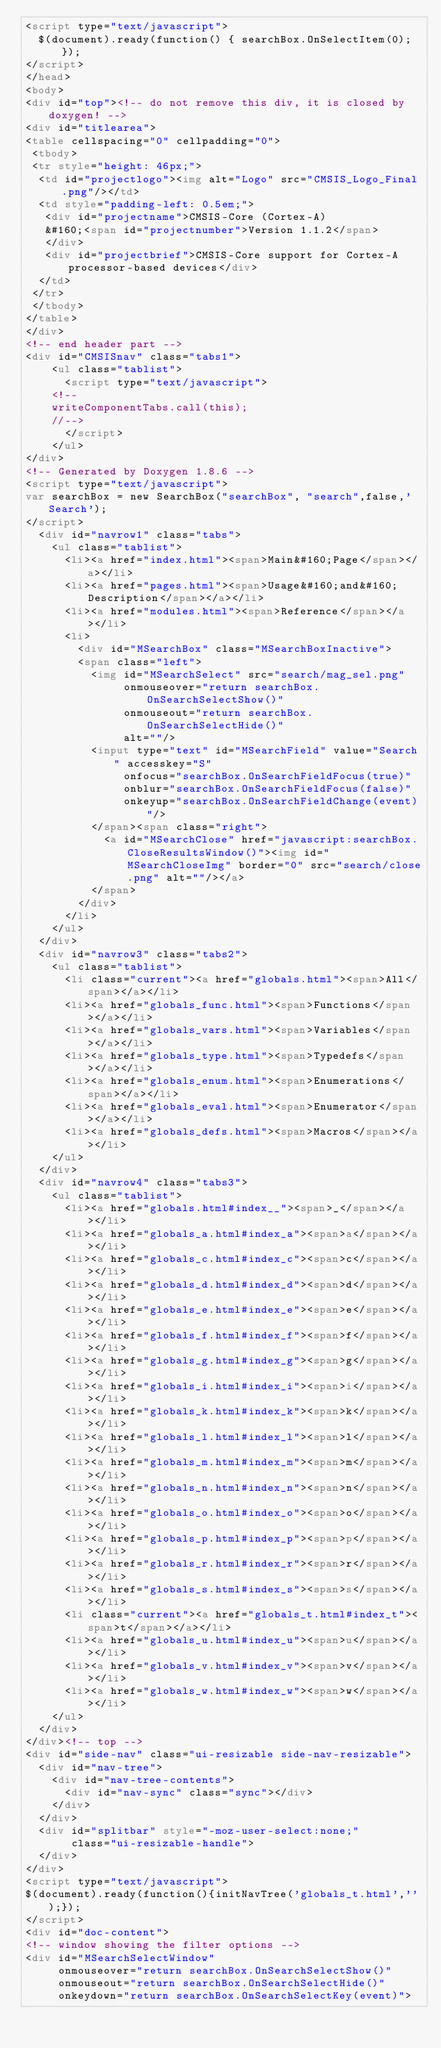Convert code to text. <code><loc_0><loc_0><loc_500><loc_500><_HTML_><script type="text/javascript">
  $(document).ready(function() { searchBox.OnSelectItem(0); });
</script>
</head>
<body>
<div id="top"><!-- do not remove this div, it is closed by doxygen! -->
<div id="titlearea">
<table cellspacing="0" cellpadding="0">
 <tbody>
 <tr style="height: 46px;">
  <td id="projectlogo"><img alt="Logo" src="CMSIS_Logo_Final.png"/></td>
  <td style="padding-left: 0.5em;">
   <div id="projectname">CMSIS-Core (Cortex-A)
   &#160;<span id="projectnumber">Version 1.1.2</span>
   </div>
   <div id="projectbrief">CMSIS-Core support for Cortex-A processor-based devices</div>
  </td>
 </tr>
 </tbody>
</table>
</div>
<!-- end header part -->
<div id="CMSISnav" class="tabs1">
    <ul class="tablist">
      <script type="text/javascript">
		<!--
		writeComponentTabs.call(this);
		//-->
      </script>
	  </ul>
</div>
<!-- Generated by Doxygen 1.8.6 -->
<script type="text/javascript">
var searchBox = new SearchBox("searchBox", "search",false,'Search');
</script>
  <div id="navrow1" class="tabs">
    <ul class="tablist">
      <li><a href="index.html"><span>Main&#160;Page</span></a></li>
      <li><a href="pages.html"><span>Usage&#160;and&#160;Description</span></a></li>
      <li><a href="modules.html"><span>Reference</span></a></li>
      <li>
        <div id="MSearchBox" class="MSearchBoxInactive">
        <span class="left">
          <img id="MSearchSelect" src="search/mag_sel.png"
               onmouseover="return searchBox.OnSearchSelectShow()"
               onmouseout="return searchBox.OnSearchSelectHide()"
               alt=""/>
          <input type="text" id="MSearchField" value="Search" accesskey="S"
               onfocus="searchBox.OnSearchFieldFocus(true)" 
               onblur="searchBox.OnSearchFieldFocus(false)" 
               onkeyup="searchBox.OnSearchFieldChange(event)"/>
          </span><span class="right">
            <a id="MSearchClose" href="javascript:searchBox.CloseResultsWindow()"><img id="MSearchCloseImg" border="0" src="search/close.png" alt=""/></a>
          </span>
        </div>
      </li>
    </ul>
  </div>
  <div id="navrow3" class="tabs2">
    <ul class="tablist">
      <li class="current"><a href="globals.html"><span>All</span></a></li>
      <li><a href="globals_func.html"><span>Functions</span></a></li>
      <li><a href="globals_vars.html"><span>Variables</span></a></li>
      <li><a href="globals_type.html"><span>Typedefs</span></a></li>
      <li><a href="globals_enum.html"><span>Enumerations</span></a></li>
      <li><a href="globals_eval.html"><span>Enumerator</span></a></li>
      <li><a href="globals_defs.html"><span>Macros</span></a></li>
    </ul>
  </div>
  <div id="navrow4" class="tabs3">
    <ul class="tablist">
      <li><a href="globals.html#index__"><span>_</span></a></li>
      <li><a href="globals_a.html#index_a"><span>a</span></a></li>
      <li><a href="globals_c.html#index_c"><span>c</span></a></li>
      <li><a href="globals_d.html#index_d"><span>d</span></a></li>
      <li><a href="globals_e.html#index_e"><span>e</span></a></li>
      <li><a href="globals_f.html#index_f"><span>f</span></a></li>
      <li><a href="globals_g.html#index_g"><span>g</span></a></li>
      <li><a href="globals_i.html#index_i"><span>i</span></a></li>
      <li><a href="globals_k.html#index_k"><span>k</span></a></li>
      <li><a href="globals_l.html#index_l"><span>l</span></a></li>
      <li><a href="globals_m.html#index_m"><span>m</span></a></li>
      <li><a href="globals_n.html#index_n"><span>n</span></a></li>
      <li><a href="globals_o.html#index_o"><span>o</span></a></li>
      <li><a href="globals_p.html#index_p"><span>p</span></a></li>
      <li><a href="globals_r.html#index_r"><span>r</span></a></li>
      <li><a href="globals_s.html#index_s"><span>s</span></a></li>
      <li class="current"><a href="globals_t.html#index_t"><span>t</span></a></li>
      <li><a href="globals_u.html#index_u"><span>u</span></a></li>
      <li><a href="globals_v.html#index_v"><span>v</span></a></li>
      <li><a href="globals_w.html#index_w"><span>w</span></a></li>
    </ul>
  </div>
</div><!-- top -->
<div id="side-nav" class="ui-resizable side-nav-resizable">
  <div id="nav-tree">
    <div id="nav-tree-contents">
      <div id="nav-sync" class="sync"></div>
    </div>
  </div>
  <div id="splitbar" style="-moz-user-select:none;" 
       class="ui-resizable-handle">
  </div>
</div>
<script type="text/javascript">
$(document).ready(function(){initNavTree('globals_t.html','');});
</script>
<div id="doc-content">
<!-- window showing the filter options -->
<div id="MSearchSelectWindow"
     onmouseover="return searchBox.OnSearchSelectShow()"
     onmouseout="return searchBox.OnSearchSelectHide()"
     onkeydown="return searchBox.OnSearchSelectKey(event)"></code> 